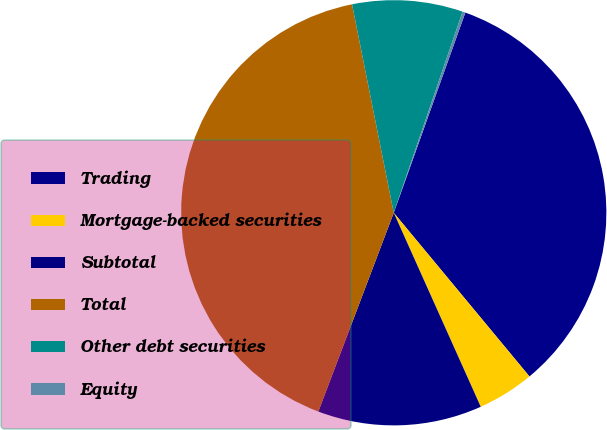Convert chart. <chart><loc_0><loc_0><loc_500><loc_500><pie_chart><fcel>Trading<fcel>Mortgage-backed securities<fcel>Subtotal<fcel>Total<fcel>Other debt securities<fcel>Equity<nl><fcel>33.52%<fcel>4.31%<fcel>12.48%<fcel>41.09%<fcel>8.39%<fcel>0.22%<nl></chart> 